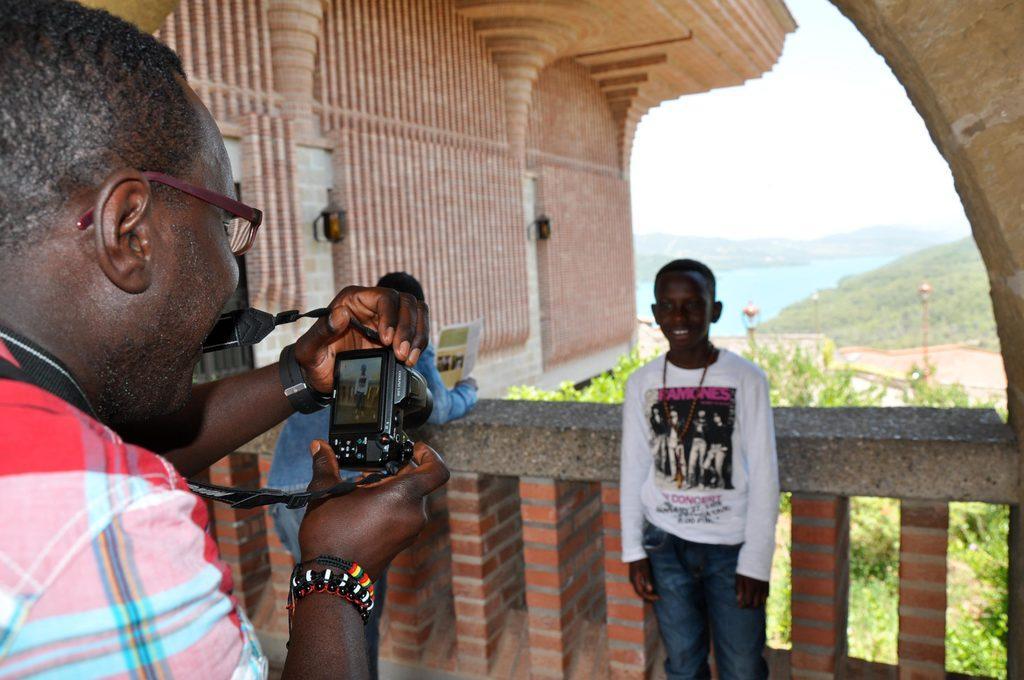How would you summarize this image in a sentence or two? In this image I can see a building, in the building I can see a person holding a camera visible on the left side , in the middle there is the wall , in front of the wall there are two persons visible, in front of building there are some plants ,the lake ,small hill and the sky visible. 